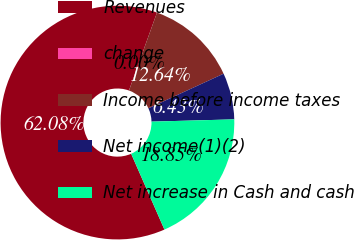Convert chart. <chart><loc_0><loc_0><loc_500><loc_500><pie_chart><fcel>Revenues<fcel>change<fcel>Income before income taxes<fcel>Net income(1)(2)<fcel>Net increase in Cash and cash<nl><fcel>62.08%<fcel>0.0%<fcel>12.64%<fcel>6.43%<fcel>18.85%<nl></chart> 